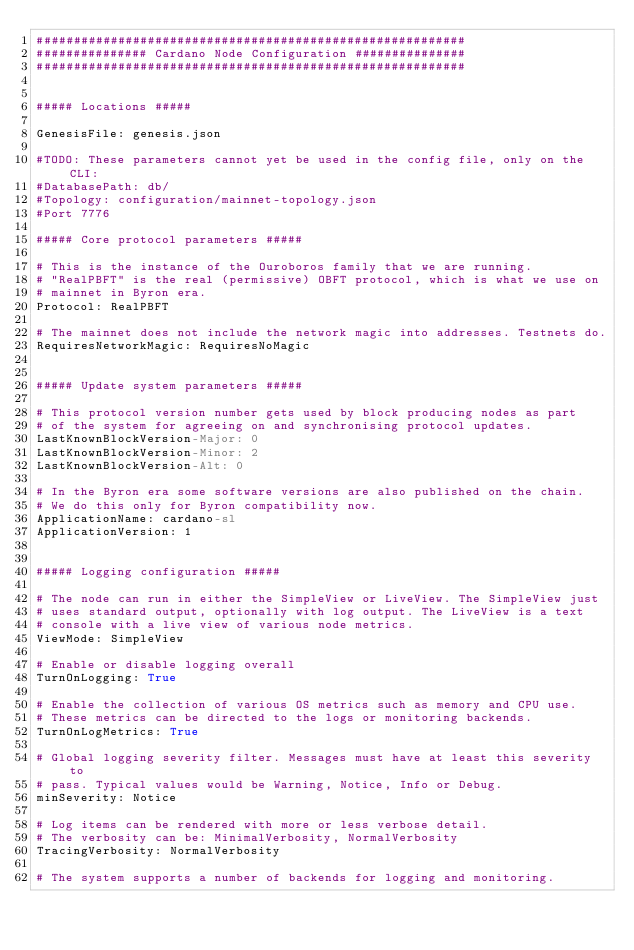Convert code to text. <code><loc_0><loc_0><loc_500><loc_500><_YAML_>##########################################################
############### Cardano Node Configuration ###############
##########################################################


##### Locations #####

GenesisFile: genesis.json

#TODO: These parameters cannot yet be used in the config file, only on the CLI:
#DatabasePath: db/
#Topology: configuration/mainnet-topology.json
#Port 7776

##### Core protocol parameters #####

# This is the instance of the Ouroboros family that we are running.
# "RealPBFT" is the real (permissive) OBFT protocol, which is what we use on
# mainnet in Byron era.
Protocol: RealPBFT

# The mainnet does not include the network magic into addresses. Testnets do.
RequiresNetworkMagic: RequiresNoMagic


##### Update system parameters #####

# This protocol version number gets used by block producing nodes as part
# of the system for agreeing on and synchronising protocol updates.
LastKnownBlockVersion-Major: 0
LastKnownBlockVersion-Minor: 2
LastKnownBlockVersion-Alt: 0

# In the Byron era some software versions are also published on the chain.
# We do this only for Byron compatibility now.
ApplicationName: cardano-sl
ApplicationVersion: 1


##### Logging configuration #####

# The node can run in either the SimpleView or LiveView. The SimpleView just
# uses standard output, optionally with log output. The LiveView is a text
# console with a live view of various node metrics.
ViewMode: SimpleView

# Enable or disable logging overall
TurnOnLogging: True

# Enable the collection of various OS metrics such as memory and CPU use.
# These metrics can be directed to the logs or monitoring backends.
TurnOnLogMetrics: True

# Global logging severity filter. Messages must have at least this severity to
# pass. Typical values would be Warning, Notice, Info or Debug.
minSeverity: Notice

# Log items can be rendered with more or less verbose detail.
# The verbosity can be: MinimalVerbosity, NormalVerbosity
TracingVerbosity: NormalVerbosity

# The system supports a number of backends for logging and monitoring.</code> 